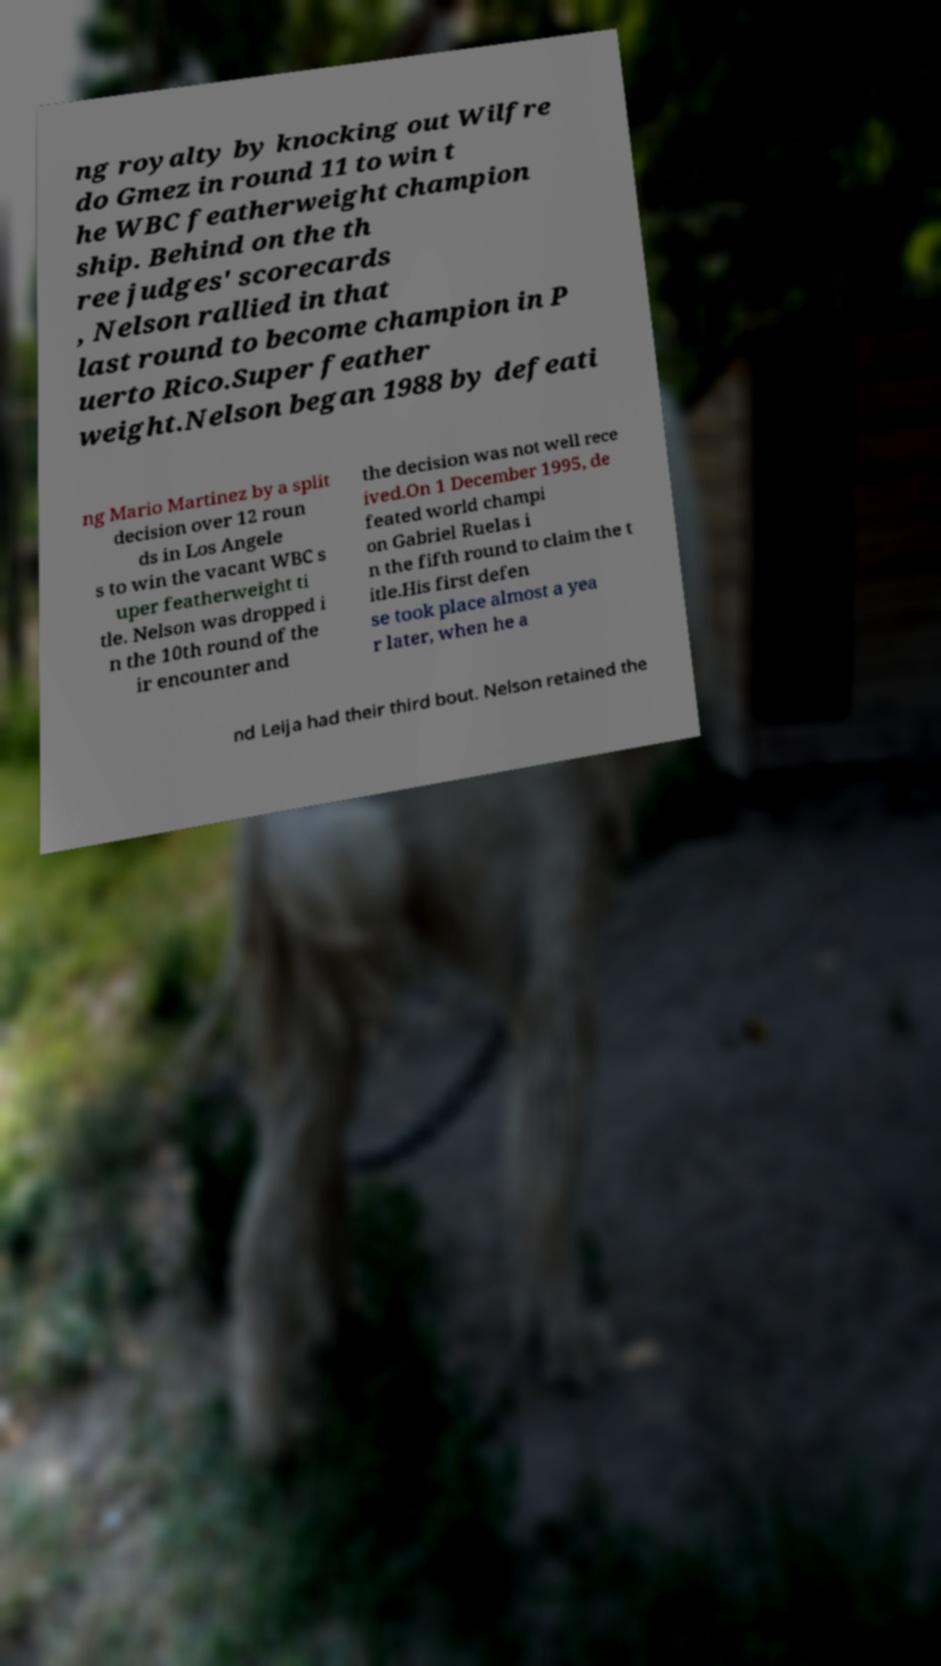What messages or text are displayed in this image? I need them in a readable, typed format. ng royalty by knocking out Wilfre do Gmez in round 11 to win t he WBC featherweight champion ship. Behind on the th ree judges' scorecards , Nelson rallied in that last round to become champion in P uerto Rico.Super feather weight.Nelson began 1988 by defeati ng Mario Martinez by a split decision over 12 roun ds in Los Angele s to win the vacant WBC s uper featherweight ti tle. Nelson was dropped i n the 10th round of the ir encounter and the decision was not well rece ived.On 1 December 1995, de feated world champi on Gabriel Ruelas i n the fifth round to claim the t itle.His first defen se took place almost a yea r later, when he a nd Leija had their third bout. Nelson retained the 